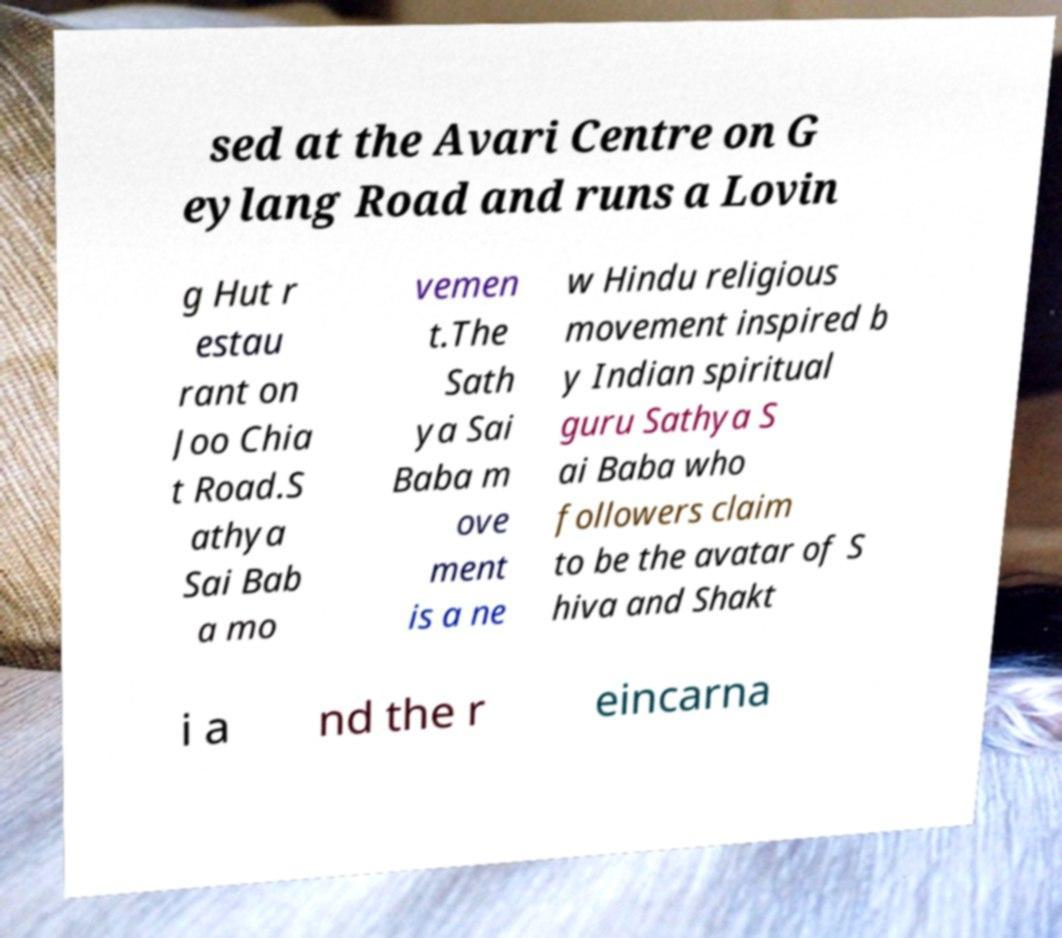What messages or text are displayed in this image? I need them in a readable, typed format. sed at the Avari Centre on G eylang Road and runs a Lovin g Hut r estau rant on Joo Chia t Road.S athya Sai Bab a mo vemen t.The Sath ya Sai Baba m ove ment is a ne w Hindu religious movement inspired b y Indian spiritual guru Sathya S ai Baba who followers claim to be the avatar of S hiva and Shakt i a nd the r eincarna 